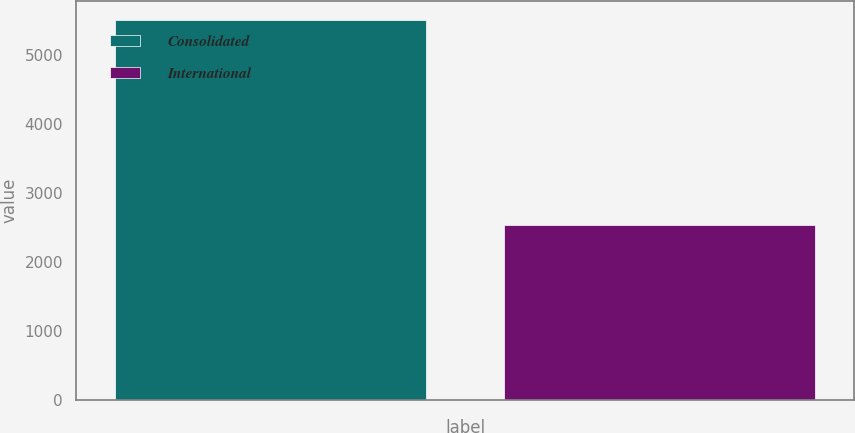<chart> <loc_0><loc_0><loc_500><loc_500><bar_chart><fcel>Consolidated<fcel>International<nl><fcel>5505.7<fcel>2533.6<nl></chart> 